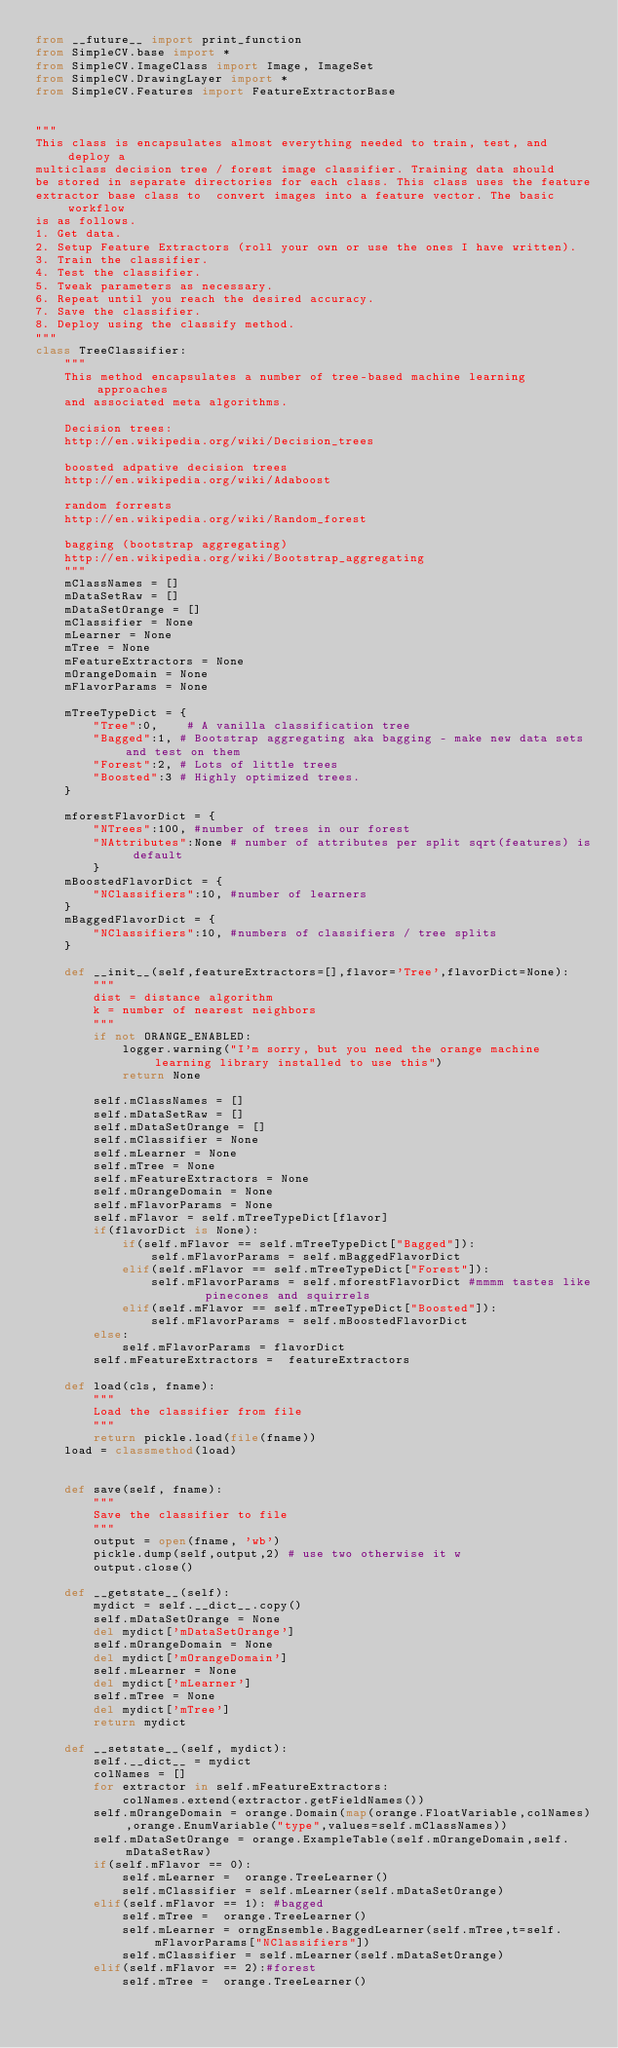Convert code to text. <code><loc_0><loc_0><loc_500><loc_500><_Python_>from __future__ import print_function
from SimpleCV.base import *
from SimpleCV.ImageClass import Image, ImageSet
from SimpleCV.DrawingLayer import *
from SimpleCV.Features import FeatureExtractorBase


"""
This class is encapsulates almost everything needed to train, test, and deploy a
multiclass decision tree / forest image classifier. Training data should
be stored in separate directories for each class. This class uses the feature
extractor base class to  convert images into a feature vector. The basic workflow
is as follows.
1. Get data.
2. Setup Feature Extractors (roll your own or use the ones I have written).
3. Train the classifier.
4. Test the classifier.
5. Tweak parameters as necessary.
6. Repeat until you reach the desired accuracy.
7. Save the classifier.
8. Deploy using the classify method.
"""
class TreeClassifier:
    """
    This method encapsulates a number of tree-based machine learning approaches
    and associated meta algorithms.

    Decision trees:
    http://en.wikipedia.org/wiki/Decision_trees

    boosted adpative decision trees
    http://en.wikipedia.org/wiki/Adaboost

    random forrests
    http://en.wikipedia.org/wiki/Random_forest

    bagging (bootstrap aggregating)
    http://en.wikipedia.org/wiki/Bootstrap_aggregating
    """
    mClassNames = []
    mDataSetRaw = []
    mDataSetOrange = []
    mClassifier = None
    mLearner = None
    mTree = None
    mFeatureExtractors = None
    mOrangeDomain = None
    mFlavorParams = None

    mTreeTypeDict = {
        "Tree":0,    # A vanilla classification tree
        "Bagged":1, # Bootstrap aggregating aka bagging - make new data sets and test on them
        "Forest":2, # Lots of little trees
        "Boosted":3 # Highly optimized trees.
    }

    mforestFlavorDict = {
        "NTrees":100, #number of trees in our forest
        "NAttributes":None # number of attributes per split sqrt(features) is default
        }
    mBoostedFlavorDict = {
        "NClassifiers":10, #number of learners
    }
    mBaggedFlavorDict = {
        "NClassifiers":10, #numbers of classifiers / tree splits
    }

    def __init__(self,featureExtractors=[],flavor='Tree',flavorDict=None):
        """
        dist = distance algorithm
        k = number of nearest neighbors
        """
        if not ORANGE_ENABLED:
            logger.warning("I'm sorry, but you need the orange machine learning library installed to use this")
            return None

        self.mClassNames = []
        self.mDataSetRaw = []
        self.mDataSetOrange = []
        self.mClassifier = None
        self.mLearner = None
        self.mTree = None
        self.mFeatureExtractors = None
        self.mOrangeDomain = None
        self.mFlavorParams = None
        self.mFlavor = self.mTreeTypeDict[flavor]
        if(flavorDict is None):
            if(self.mFlavor == self.mTreeTypeDict["Bagged"]):
                self.mFlavorParams = self.mBaggedFlavorDict
            elif(self.mFlavor == self.mTreeTypeDict["Forest"]):
                self.mFlavorParams = self.mforestFlavorDict #mmmm tastes like   pinecones and squirrels
            elif(self.mFlavor == self.mTreeTypeDict["Boosted"]):
                self.mFlavorParams = self.mBoostedFlavorDict
        else:
            self.mFlavorParams = flavorDict
        self.mFeatureExtractors =  featureExtractors

    def load(cls, fname):
        """
        Load the classifier from file
        """
        return pickle.load(file(fname))
    load = classmethod(load)


    def save(self, fname):
        """
        Save the classifier to file
        """
        output = open(fname, 'wb')
        pickle.dump(self,output,2) # use two otherwise it w
        output.close()

    def __getstate__(self):
        mydict = self.__dict__.copy()
        self.mDataSetOrange = None
        del mydict['mDataSetOrange']
        self.mOrangeDomain = None
        del mydict['mOrangeDomain']
        self.mLearner = None
        del mydict['mLearner']
        self.mTree = None
        del mydict['mTree']
        return mydict

    def __setstate__(self, mydict):
        self.__dict__ = mydict
        colNames = []
        for extractor in self.mFeatureExtractors:
            colNames.extend(extractor.getFieldNames())
        self.mOrangeDomain = orange.Domain(map(orange.FloatVariable,colNames),orange.EnumVariable("type",values=self.mClassNames))
        self.mDataSetOrange = orange.ExampleTable(self.mOrangeDomain,self.mDataSetRaw)
        if(self.mFlavor == 0):
            self.mLearner =  orange.TreeLearner()
            self.mClassifier = self.mLearner(self.mDataSetOrange)
        elif(self.mFlavor == 1): #bagged
            self.mTree =  orange.TreeLearner()
            self.mLearner = orngEnsemble.BaggedLearner(self.mTree,t=self.mFlavorParams["NClassifiers"])
            self.mClassifier = self.mLearner(self.mDataSetOrange)
        elif(self.mFlavor == 2):#forest
            self.mTree =  orange.TreeLearner()</code> 